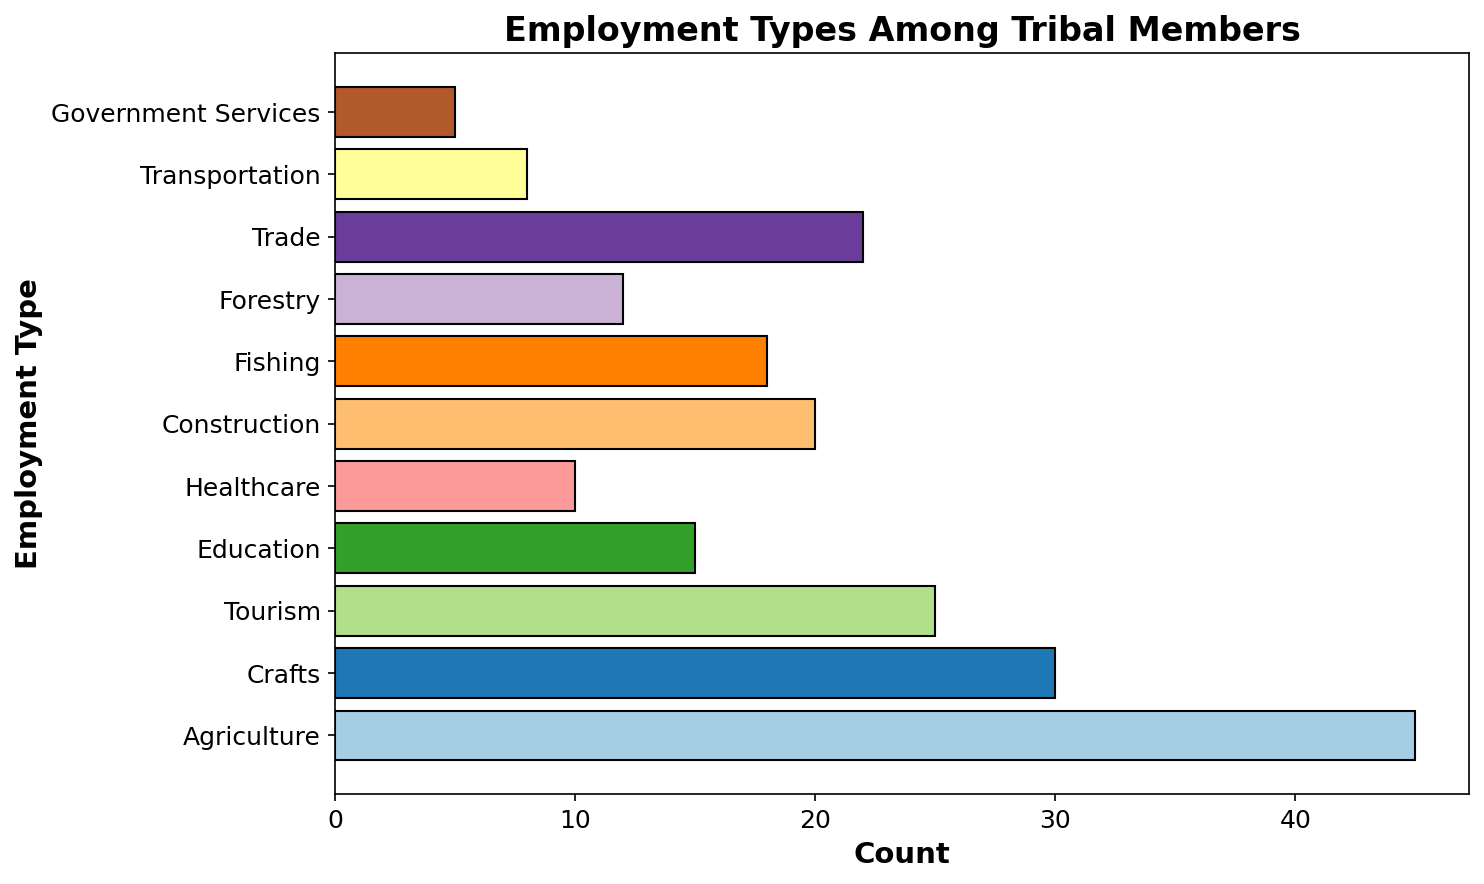Which employment type has the highest count? The bar for "Agriculture" extends the farthest to the right, indicating it has the highest count.
Answer: Agriculture Which employment type has the lowest count? The bar for "Government Services" is the shortest, indicating it has the lowest count.
Answer: Government Services What is the total count of members employed in Agriculture and Crafts? The count for Agriculture is 45 and for Crafts is 30, so 45 + 30 = 75.
Answer: 75 How does the count of members in Healthcare compare to those in Forestry? The count for Healthcare is 10 while for Forestry it is 12, so Healthcare has fewer members than Forestry.
Answer: Healthcare has fewer members Which employment types have a count above 20? The bars that extend beyond the 20 mark are for Agriculture (45), Crafts (30), and Trade (22).
Answer: Agriculture, Crafts, Trade How many more members are employed in Tourism than in Transportation? Tourism has a count of 25 while Transportation has 8. The difference is 25 - 8 = 17.
Answer: 17 Are there more members employed in Construction or Fishing? The count for Construction is 20 and for Fishing it is 18. Therefore, Construction has more members.
Answer: Construction What is the average count of members employed in Education, Healthcare, and Government Services? The counts are Education (15), Healthcare (10), and Government Services (5). The sum is 15 + 10 + 5 = 30. The average is 30 / 3 = 10.
Answer: 10 Which employment type, between Trade and Forestry, has a higher count? The count for Trade is 22 while for Forestry it is 12, so Trade has a higher count.
Answer: Trade What is the sum of members employed in Tourism, Education, and Transportation? The counts are Tourism (25), Education (15), and Transportation (8). The sum is 25 + 15 + 8 = 48.
Answer: 48 